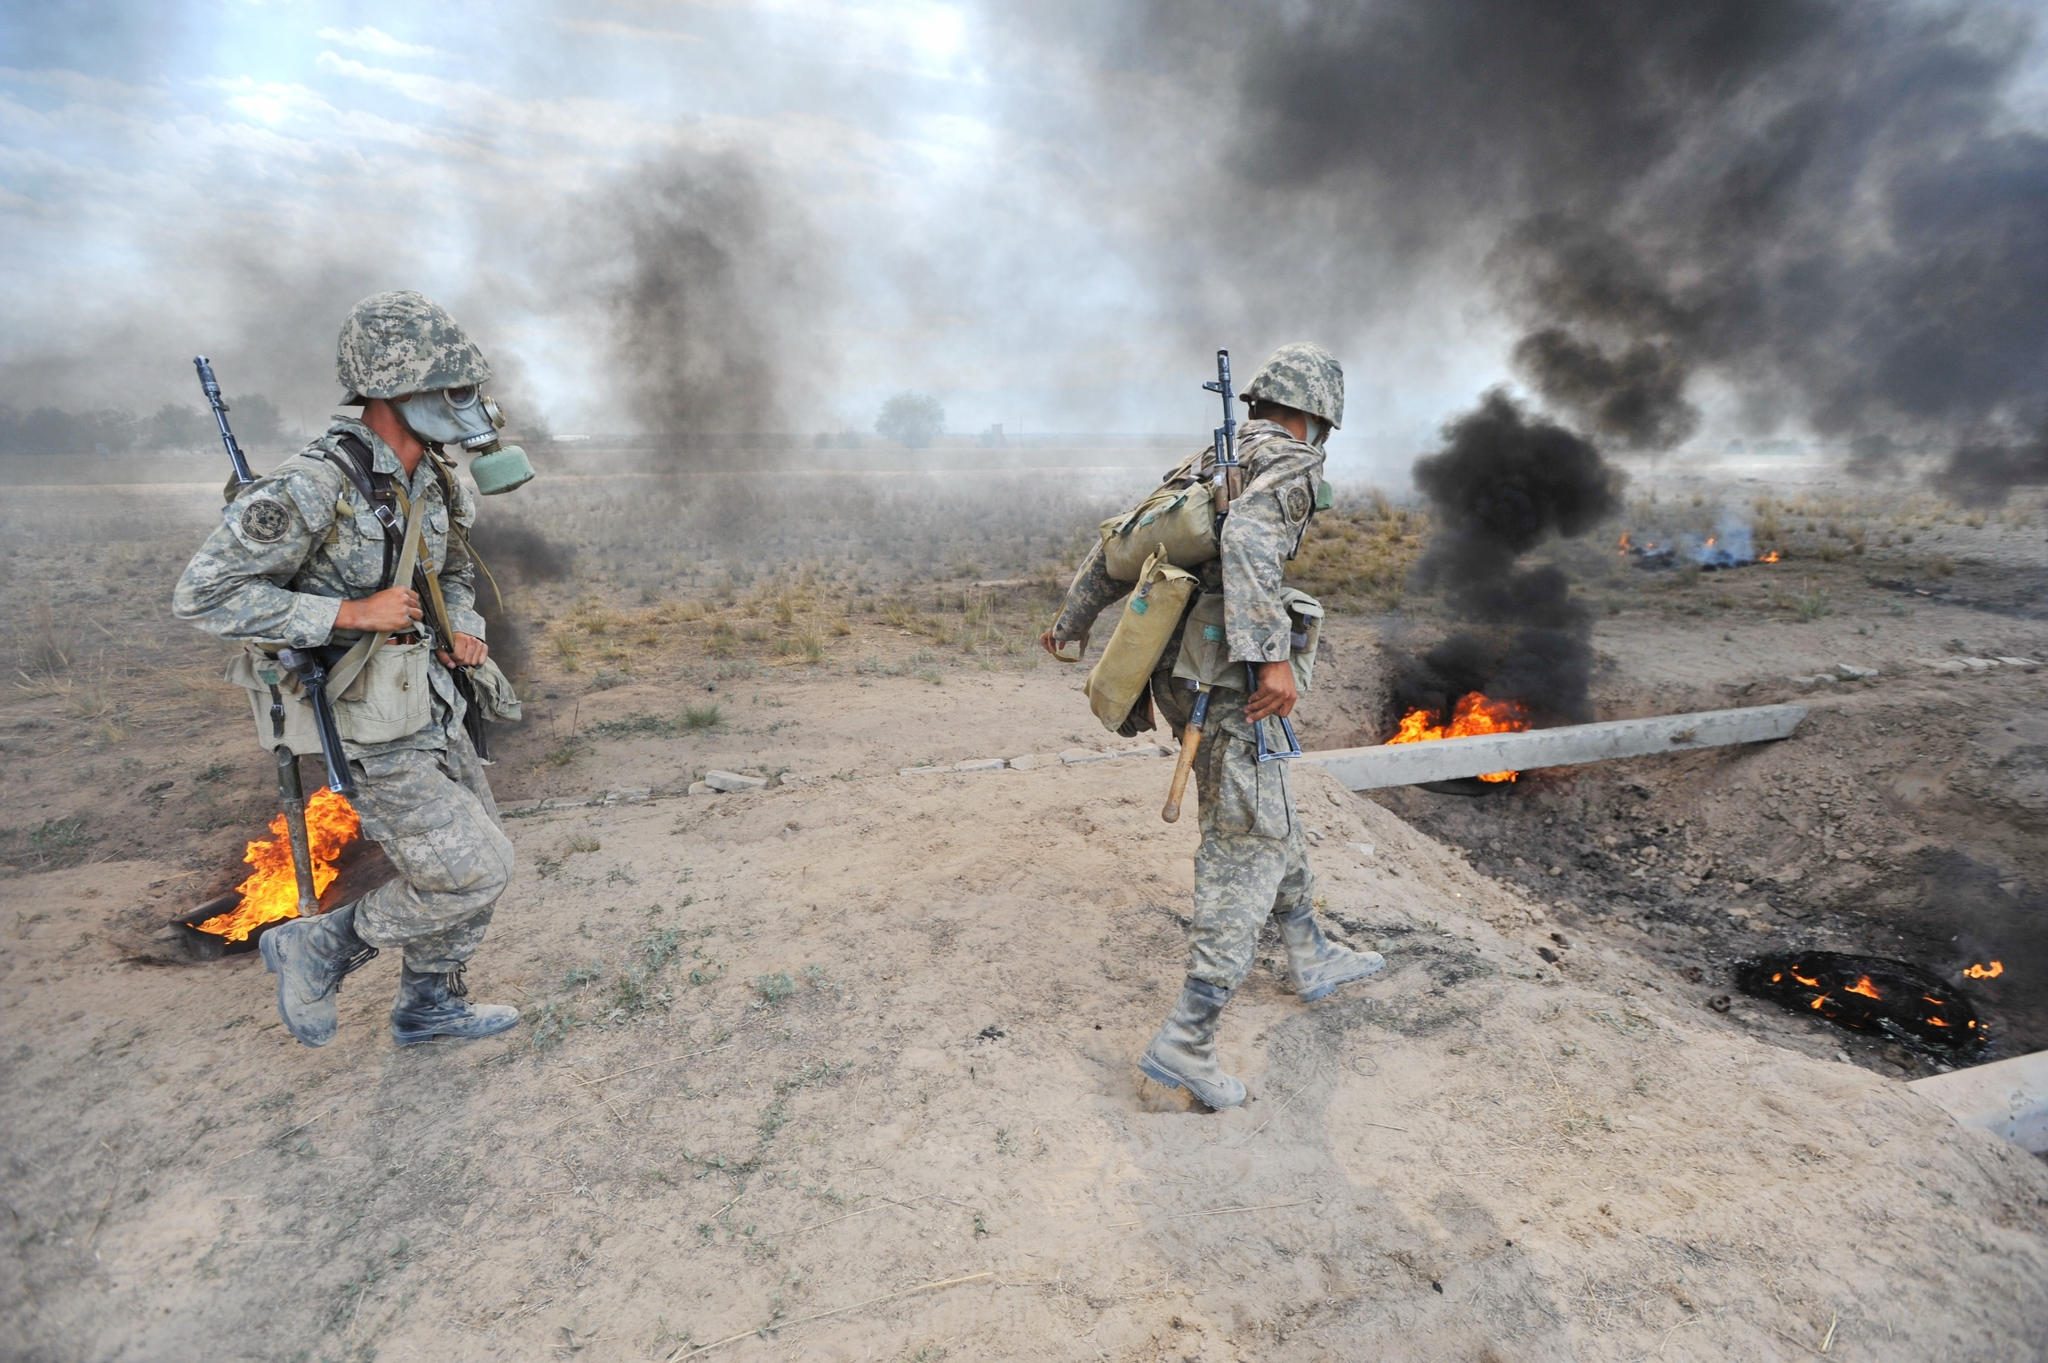What emotions or psychological states might the soldiers be experiencing in this image? The soldiers might be experiencing a mixture of emotions in this intense situation. There could be a sense of urgency and alertness due to the immediate danger of the flames and smoke. Elements of anxiety or stress are also likely, given the high-stakes environment. However, the fact that they are moving away might bring a small sense of relief or accomplishment if they have successfully completed their objective. There's also a possibility of fatigue from the physical and mental demands of their mission. Imagine and describe a futuristic technology that could significantly assist soldiers in this scenario. In a futuristic scenario, soldiers could be assisted by autonomous drones equipped with advanced artificial intelligence and real-time data analytics. These drones could provide real-time reconnaissance, mapping out safe paths through dangerous terrain while identifying and neutralizing threats. They could also deploy miniature fire suppression systems to control flames and provide medical aid by scanning for injuries and administering care. Additionally, augmented reality (AR) helmets could overlay critical information directly onto the soldiers' visors, providing strategic directions, identifying threats, and suggesting optimal routes to enhance their situational awareness and decision-making capabilities. 